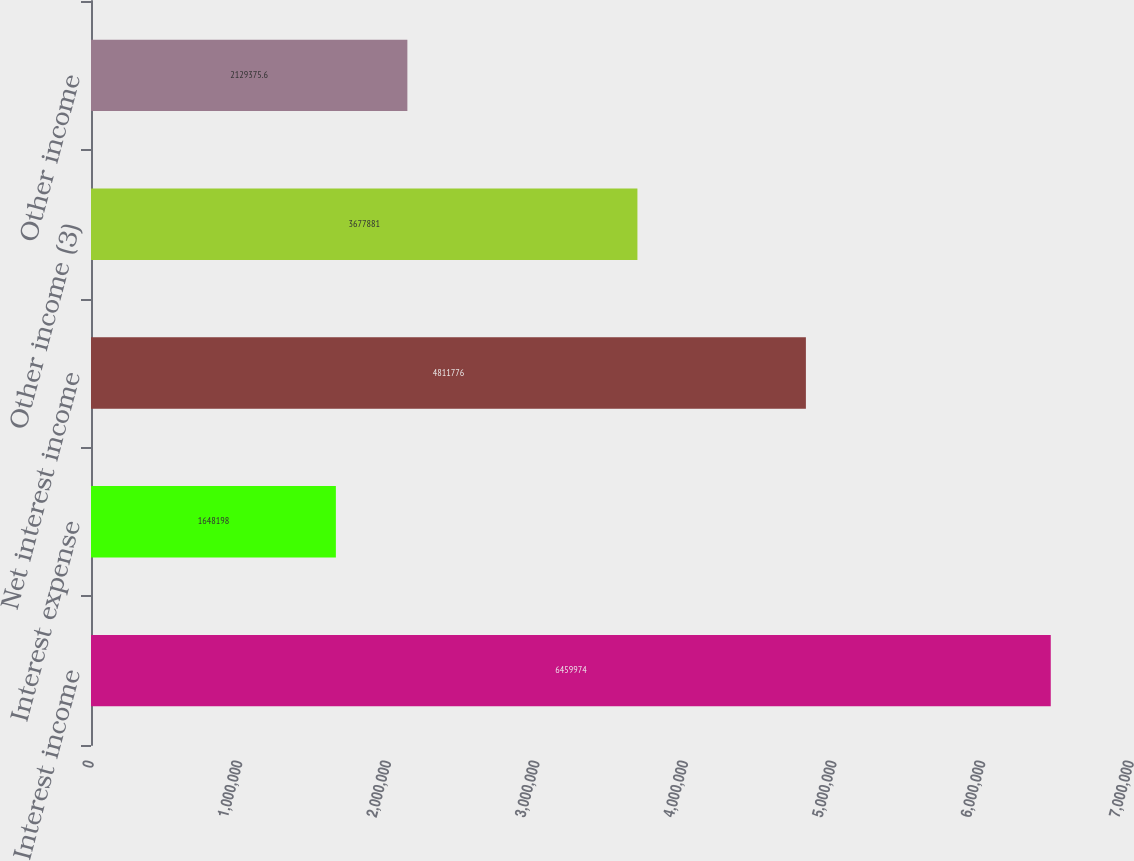<chart> <loc_0><loc_0><loc_500><loc_500><bar_chart><fcel>Interest income<fcel>Interest expense<fcel>Net interest income<fcel>Other income (3)<fcel>Other income<nl><fcel>6.45997e+06<fcel>1.6482e+06<fcel>4.81178e+06<fcel>3.67788e+06<fcel>2.12938e+06<nl></chart> 